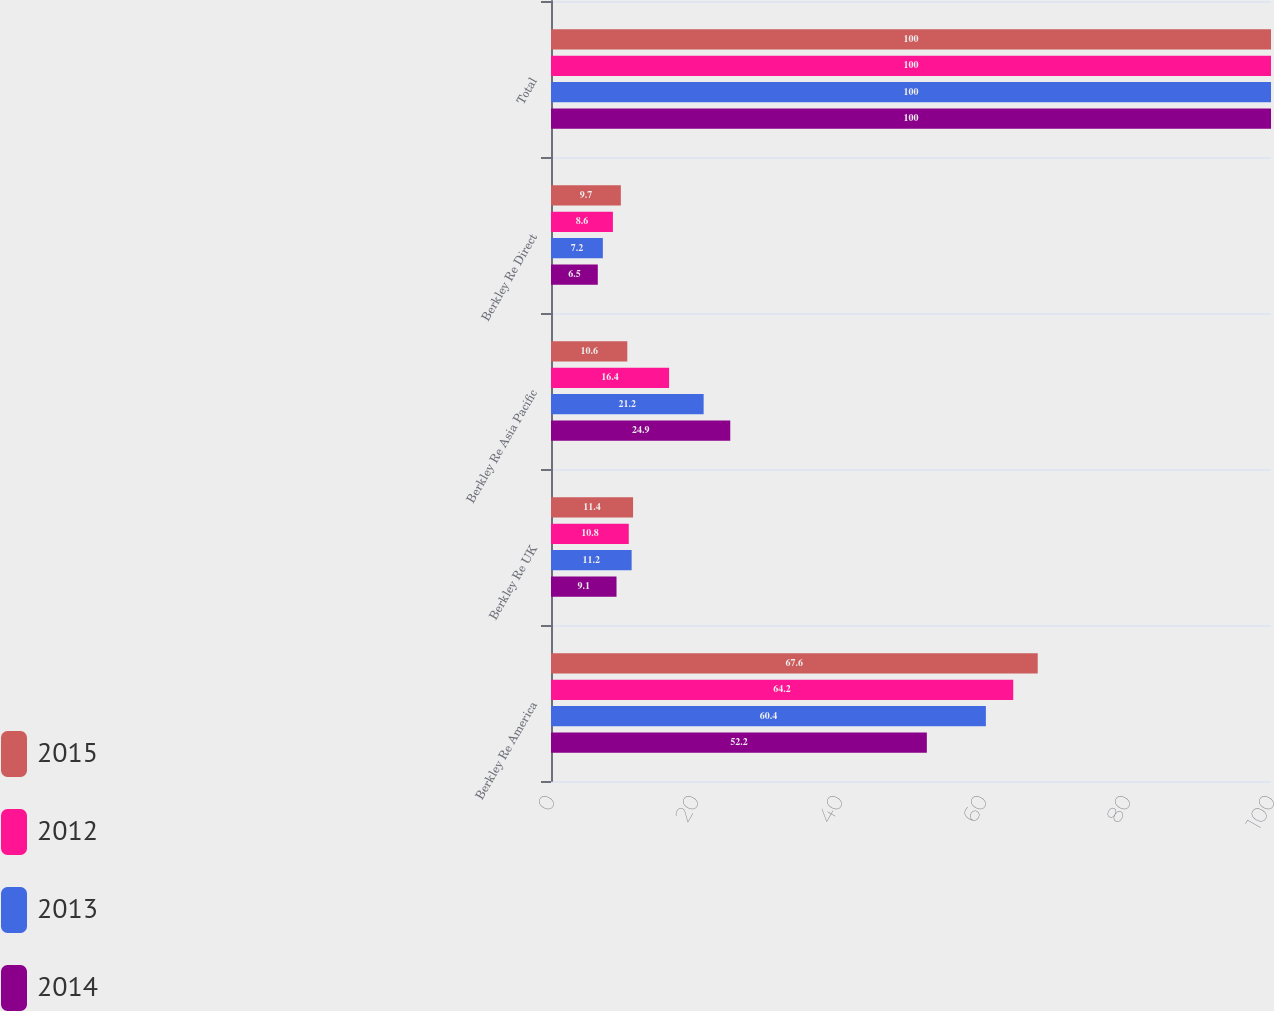<chart> <loc_0><loc_0><loc_500><loc_500><stacked_bar_chart><ecel><fcel>Berkley Re America<fcel>Berkley Re UK<fcel>Berkley Re Asia Pacific<fcel>Berkley Re Direct<fcel>Total<nl><fcel>2015<fcel>67.6<fcel>11.4<fcel>10.6<fcel>9.7<fcel>100<nl><fcel>2012<fcel>64.2<fcel>10.8<fcel>16.4<fcel>8.6<fcel>100<nl><fcel>2013<fcel>60.4<fcel>11.2<fcel>21.2<fcel>7.2<fcel>100<nl><fcel>2014<fcel>52.2<fcel>9.1<fcel>24.9<fcel>6.5<fcel>100<nl></chart> 